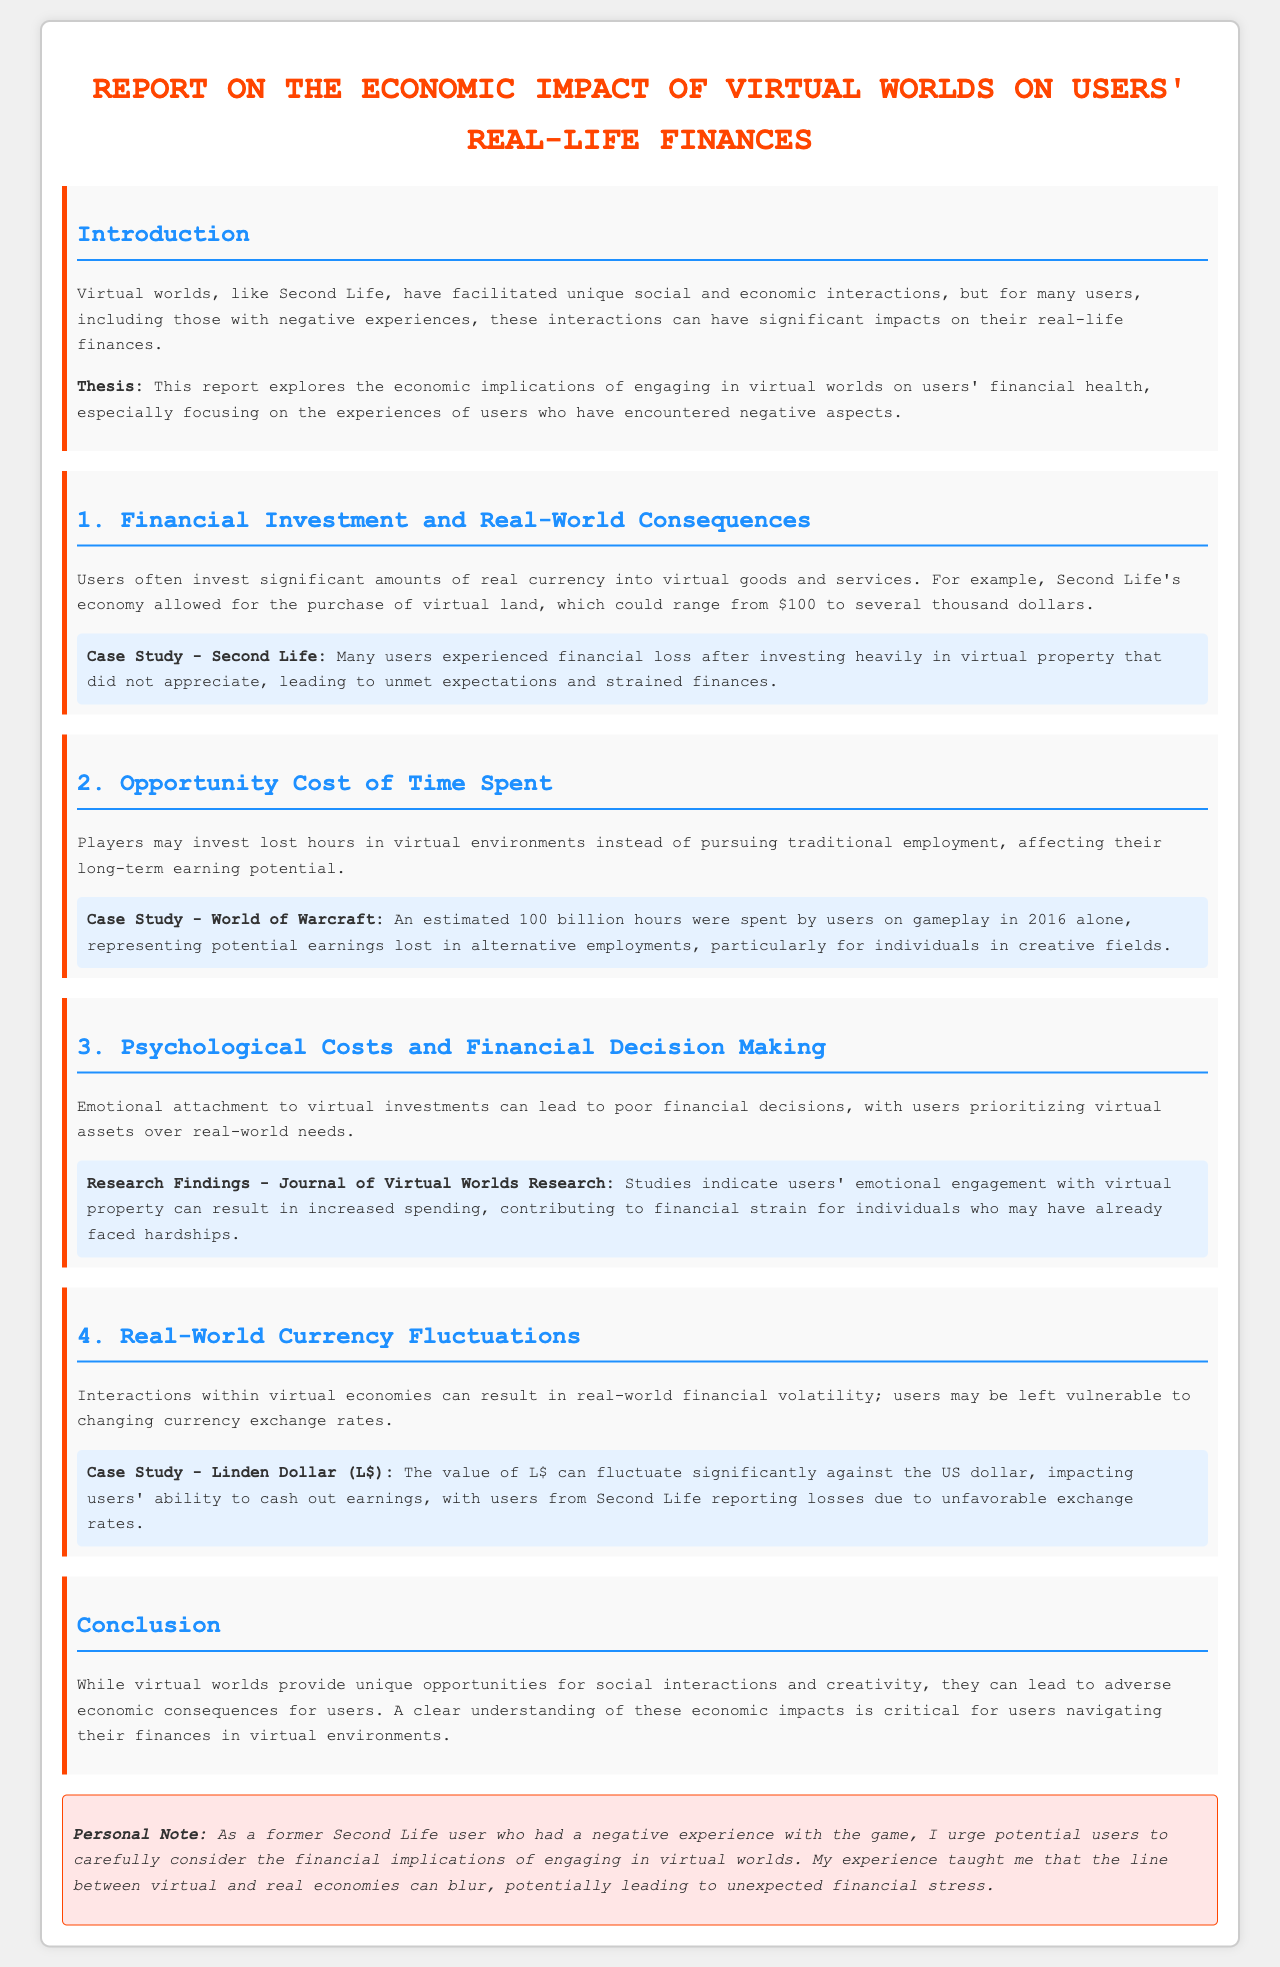What is the title of the report? The title of the report is located at the top of the document, stating the main focus of the study.
Answer: Report on the Economic Impact of Virtual Worlds on Users' Real-Life Finances What is the case study related to Second Life? The case study discusses the financial experiences of users who invested heavily in virtual property.
Answer: Many users experienced financial loss after investing heavily in virtual property that did not appreciate What year was the estimated time spent on World of Warcraft? The document specifies the year in which the estimated time spent in the game was calculated.
Answer: 2016 What emotional effect can virtual investments have on users? The report highlights a negative impact of emotional attachment to virtual investments leading to poor financial choices.
Answer: Poor financial decisions What can fluctuate significantly against the US dollar? The document mentions a specific currency related to the virtual world economy.
Answer: Linden Dollar (L$) What does the report warn potential users to consider? This warning suggests that users should be careful about the financial aspects of engaging with virtual worlds.
Answer: Financial implications 